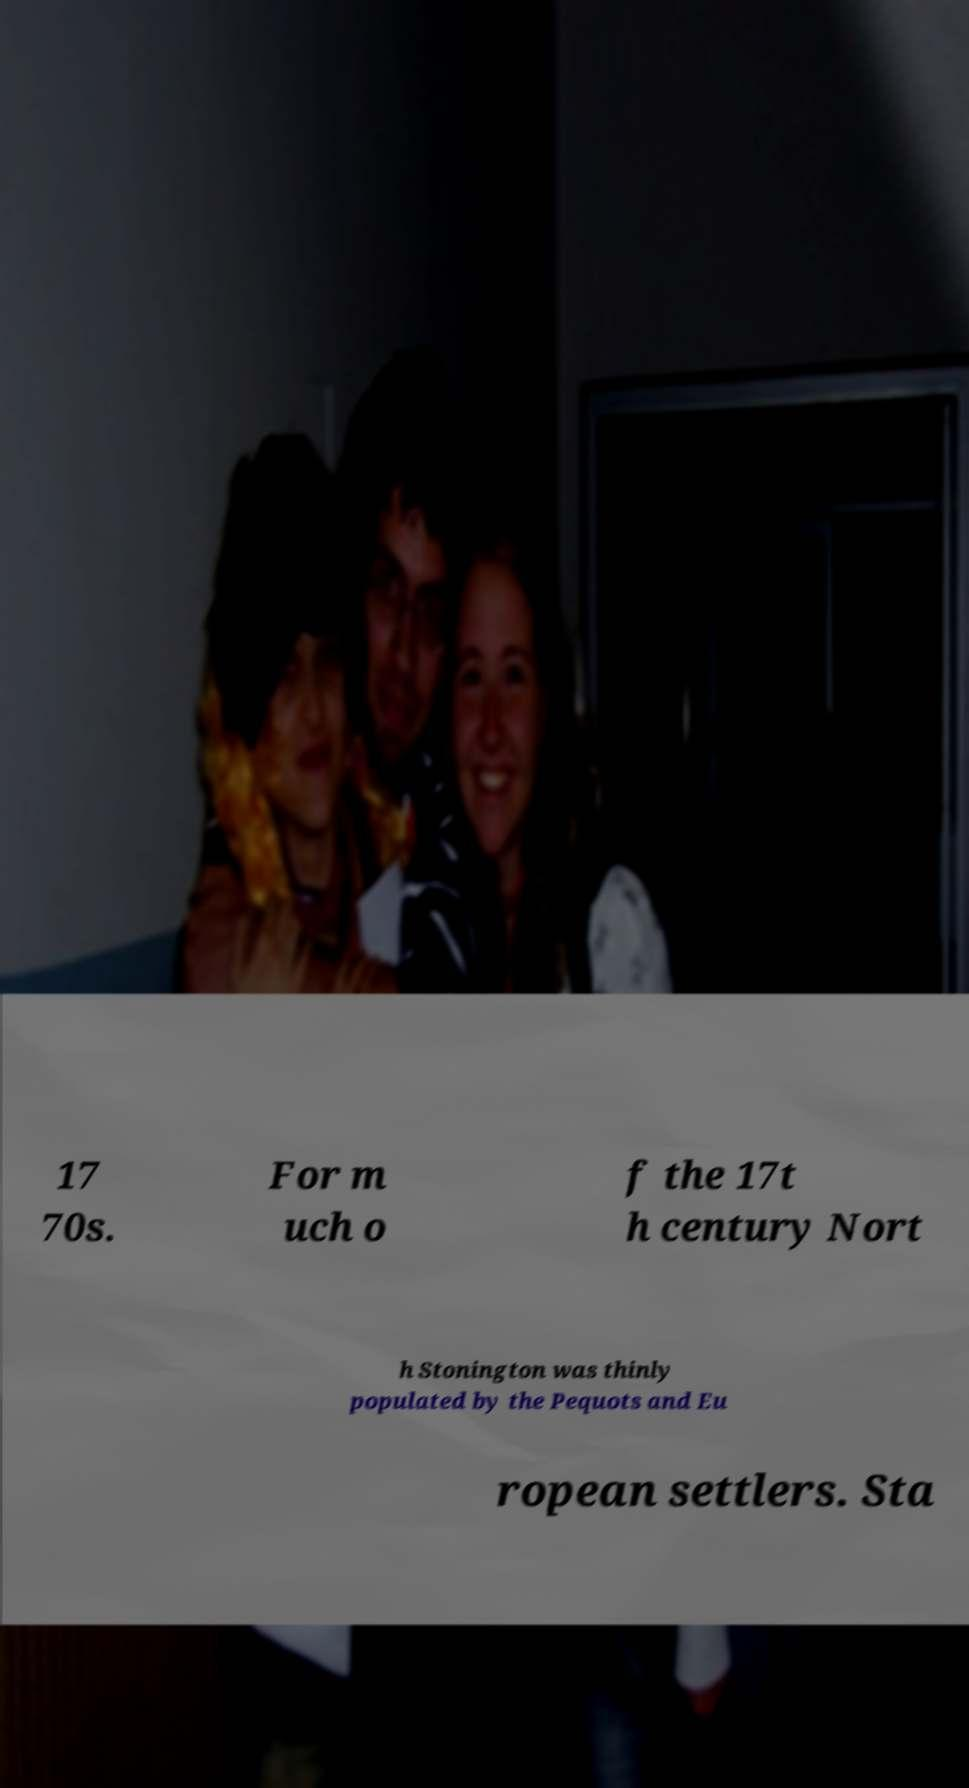Could you assist in decoding the text presented in this image and type it out clearly? 17 70s. For m uch o f the 17t h century Nort h Stonington was thinly populated by the Pequots and Eu ropean settlers. Sta 